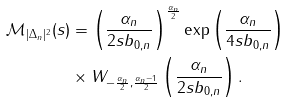<formula> <loc_0><loc_0><loc_500><loc_500>\mathcal { M } _ { | \Delta _ { n } | ^ { 2 } } ( s ) & = \left ( \frac { \alpha _ { n } } { 2 s b _ { 0 , n } } \right ) ^ { \frac { \alpha _ { n } } { 2 } } \exp \left ( \frac { \alpha _ { n } } { 4 s b _ { 0 , n } } \right ) \\ & \times W _ { - \frac { \alpha _ { n } } { 2 } , \frac { \alpha _ { n } - 1 } { 2 } } \left ( \frac { \alpha _ { n } } { 2 s b _ { 0 , n } } \right ) .</formula> 